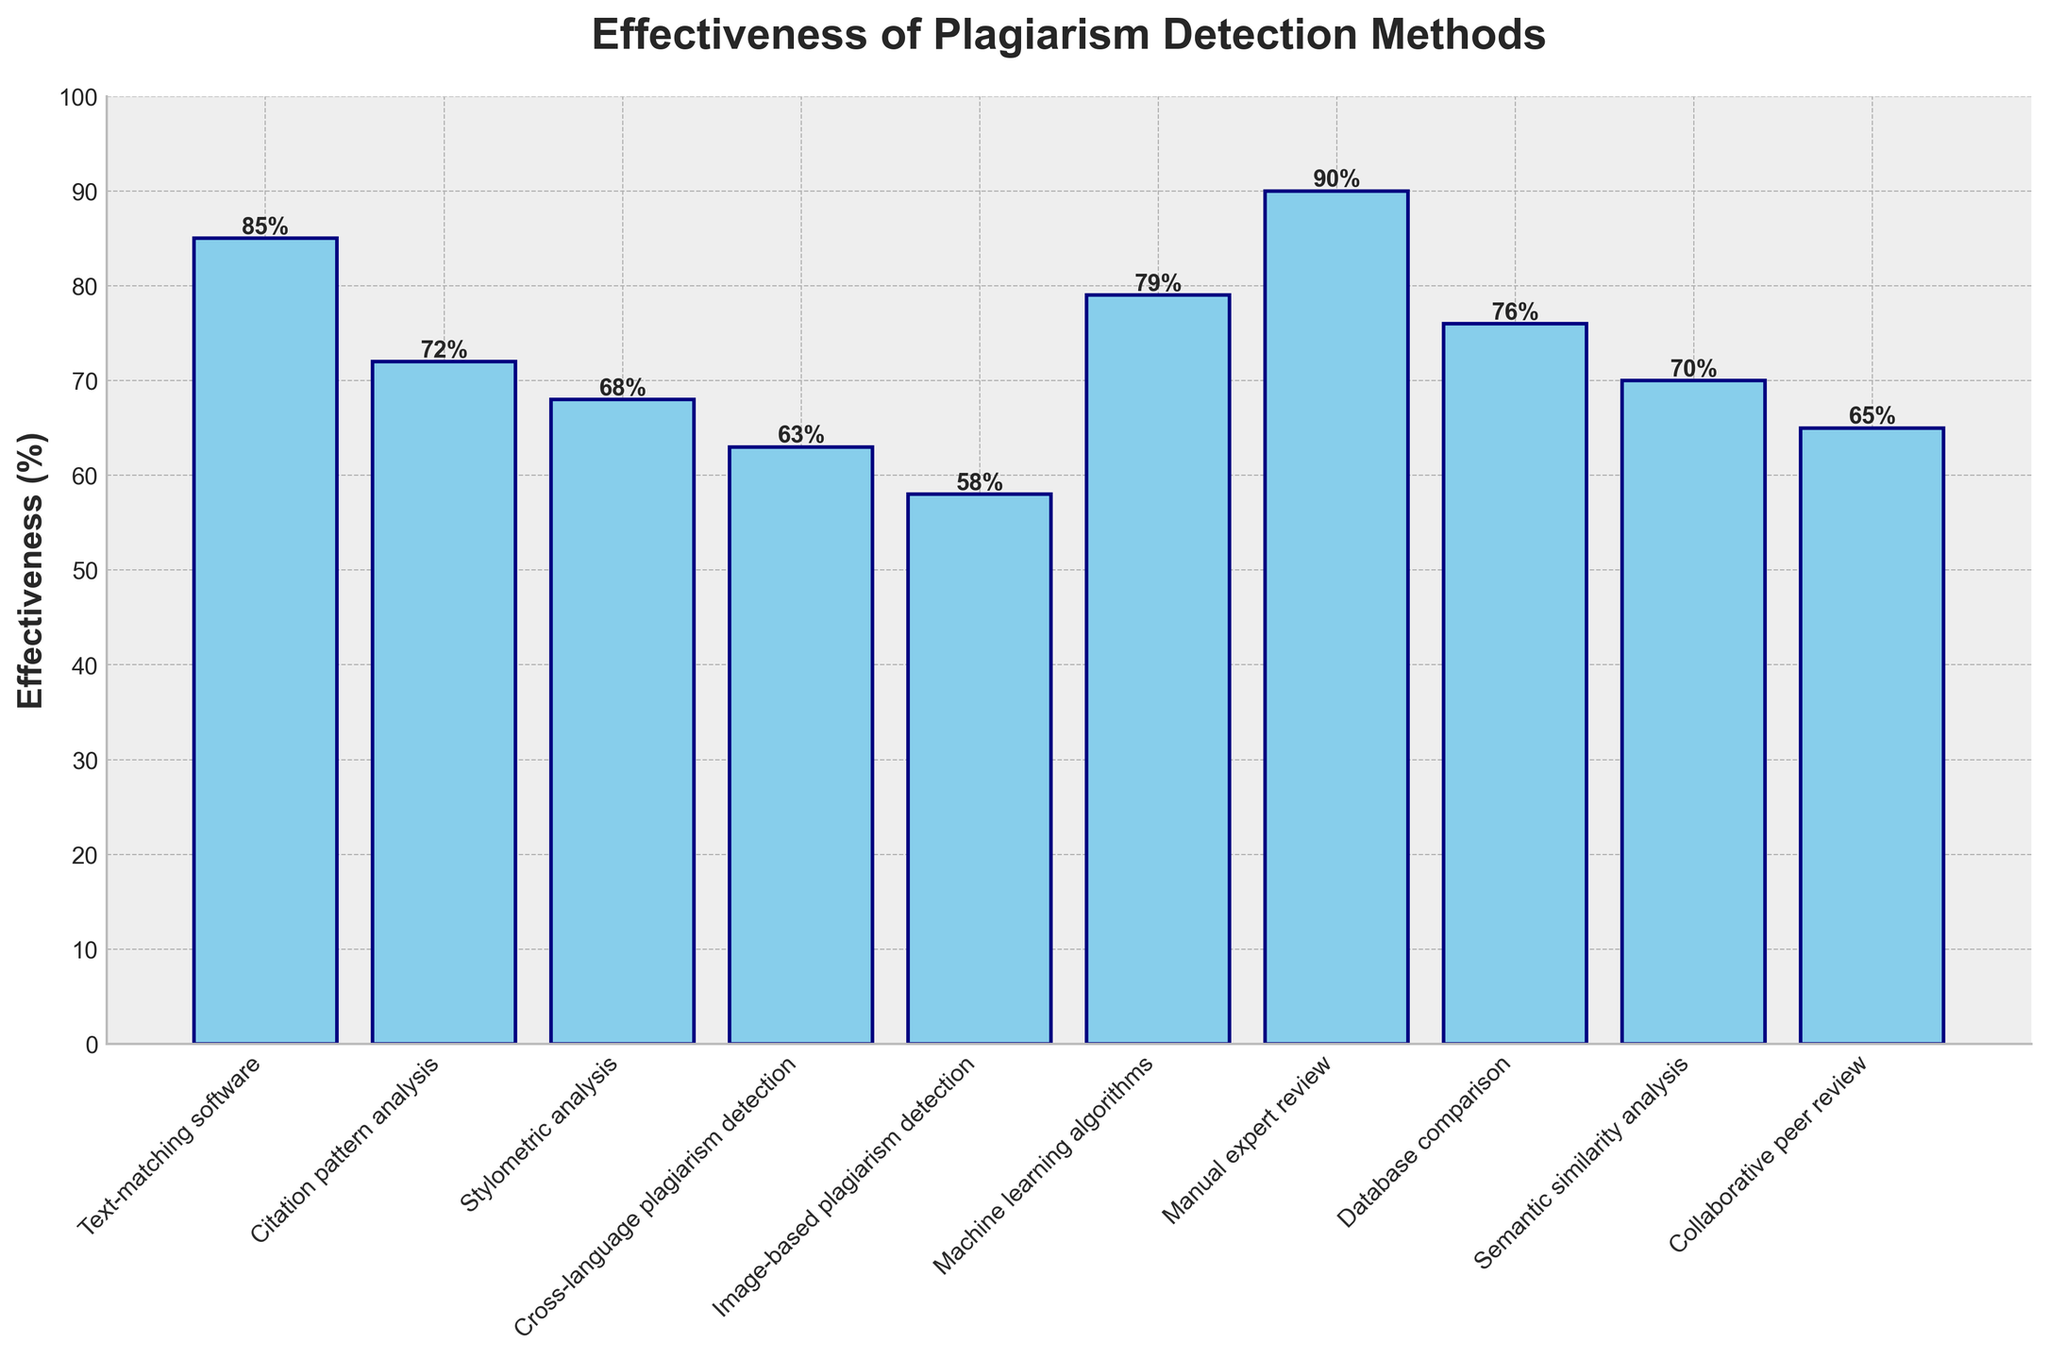Which method is the most effective for detecting plagiarism? The height of the bars represents effectiveness. The tallest bar is for Manual expert review at 90%.
Answer: Manual expert review How does the effectiveness of text-matching software compare to manual expert review? Text-matching software has an effectiveness of 85%, while manual expert review has 90%. 85% is less than 90%.
Answer: Less effective What is the total effectiveness percentage for text-matching software and machine learning algorithms combined? The effectiveness values are 85% for text-matching software and 79% for machine learning algorithms. Summing these gives 85% + 79% = 164%.
Answer: 164% Among the listed methods, which has the lowest effectiveness for detecting plagiarism? The shortest bar represents the method with the lowest effectiveness. Image-based plagiarism detection has an effectiveness of 58%.
Answer: Image-based plagiarism detection What is the difference in effectiveness between citation pattern analysis and database comparison? Citation pattern analysis has an effectiveness of 72%, while database comparison has 76%. The difference is 76% - 72% = 4%.
Answer: 4% Which methods have an effectiveness greater than 75%? The bars depicting methods with an effectiveness greater than 75% belong to text-matching software (85%), machine learning algorithms (79%), manual expert review (90%), and database comparison (76%).
Answer: Text-matching software, machine learning algorithms, manual expert review, database comparison Compare the effectiveness of semantic similarity analysis and citation pattern analysis. Which one is more effective? Semantic similarity analysis has an effectiveness of 70%, while citation pattern analysis has 72%. 72% is greater than 70%.
Answer: Citation pattern analysis What is the average effectiveness of the five least effective methods? The least effective methods are Image-based plagiarism detection (58%), Cross-language plagiarism detection (63%), Collaborative peer review (65%), Stylometric analysis (68%), and Semantic similarity analysis (70%). Their average effectiveness is calculated as (58 + 63 + 65 + 68 + 70) / 5 = 64.8%.
Answer: 64.8% How much more effective is manual expert review compared to image-based plagiarism detection? Manual expert review has an effectiveness of 90%, while image-based plagiarism detection has 58%. The difference is 90% - 58% = 32%.
Answer: 32% 